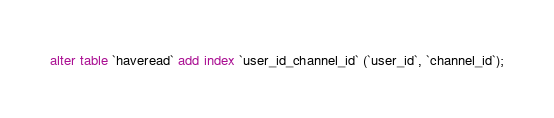<code> <loc_0><loc_0><loc_500><loc_500><_SQL_>alter table `haveread` add index `user_id_channel_id` (`user_id`, `channel_id`);</code> 